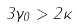<formula> <loc_0><loc_0><loc_500><loc_500>3 \gamma _ { 0 } > 2 \kappa</formula> 